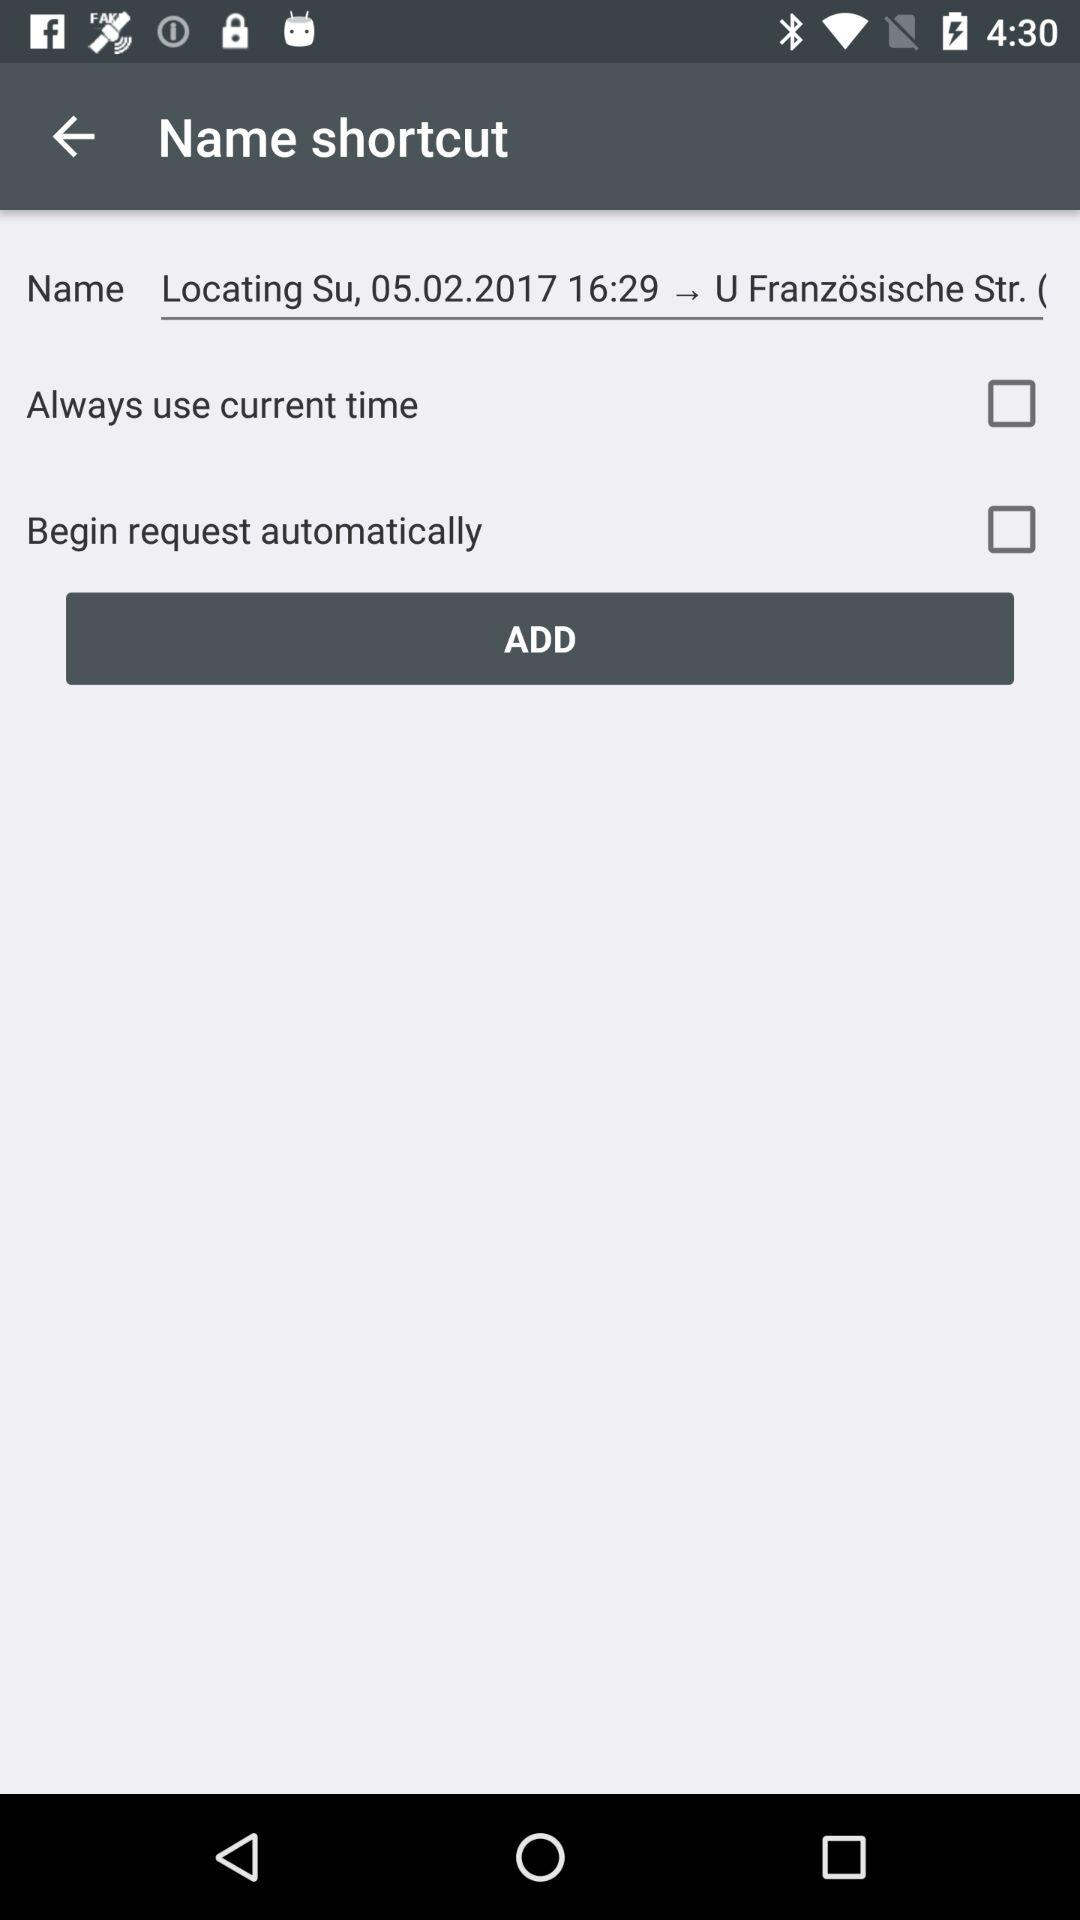What is the status of "Begin request automatically"? The status is "off". 